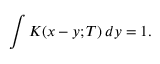<formula> <loc_0><loc_0><loc_500><loc_500>\int K ( x - y ; T ) \, d y = 1 .</formula> 